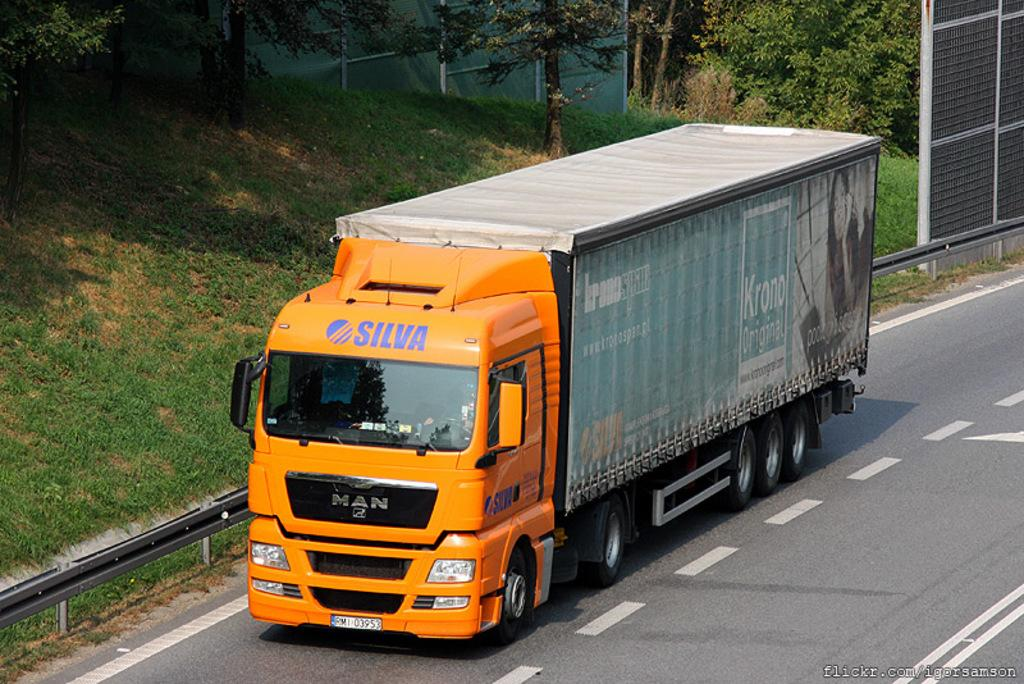What is the main subject of the image? The main subject of the image is a truck. What is the truck doing in the image? The truck is moving on the road in the image. What can be seen beside the truck? There is greenery beside the truck. What type of vegetation is present in the greenery? There are trees in the greenery. What type of pet can be seen sitting on the leather seat inside the truck? There is no pet visible inside the truck, and there is no mention of leather seats in the image. 